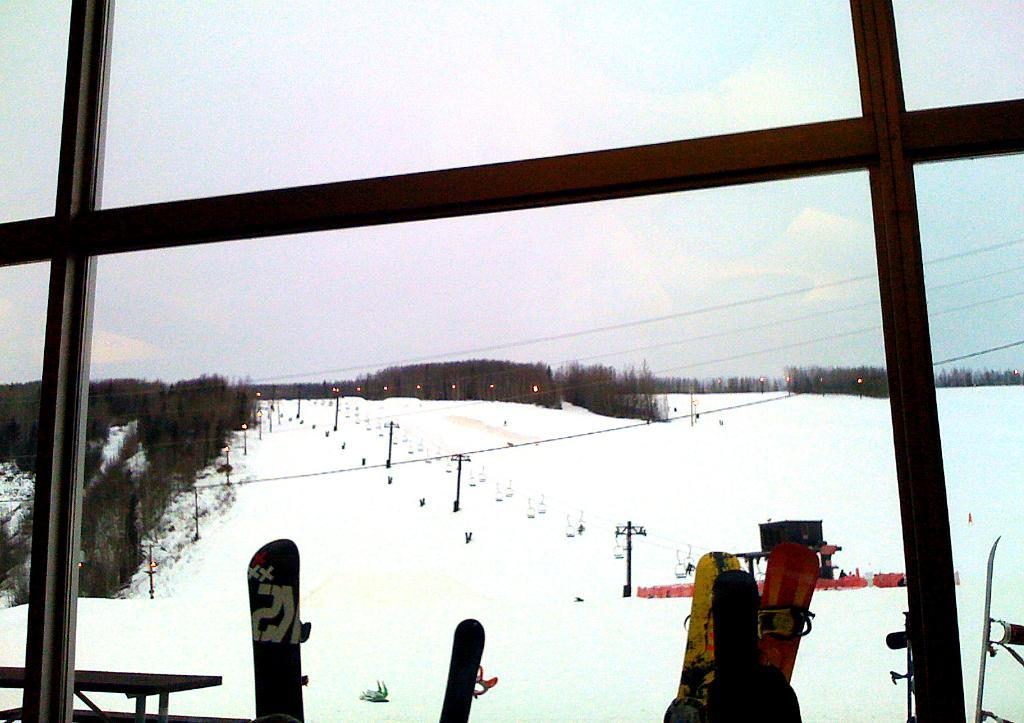What type of sports equipment can be seen in the image? There are snowboards in the image. What are the poles used for in the image? The poles are likely used for skiing or snowboarding in the image. What are the wires connected to in the image? The wires are connected to the lights in the image. What type of vegetation is present in the image? There are trees in the image. What is the ground covered with in the image? There is snow in the image. Can you describe any other objects in the image? There are some objects in the image, but their specific purpose is not clear. What can be seen in the background of the image? The sky is visible in the background of the image. How many robins are perched on the snowboards in the image? There are no robins present in the image. What type of fact is being presented in the image? The image does not present any facts; it is a visual representation of a scene. 